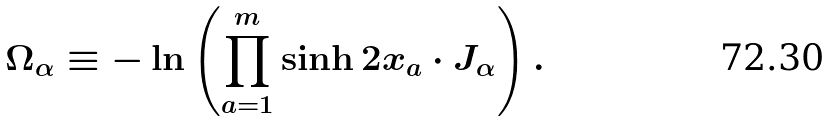<formula> <loc_0><loc_0><loc_500><loc_500>\Omega _ { \alpha } \equiv - \ln \left ( \prod _ { a = 1 } ^ { m } \sinh 2 x _ { a } \cdot J _ { \alpha } \right ) .</formula> 